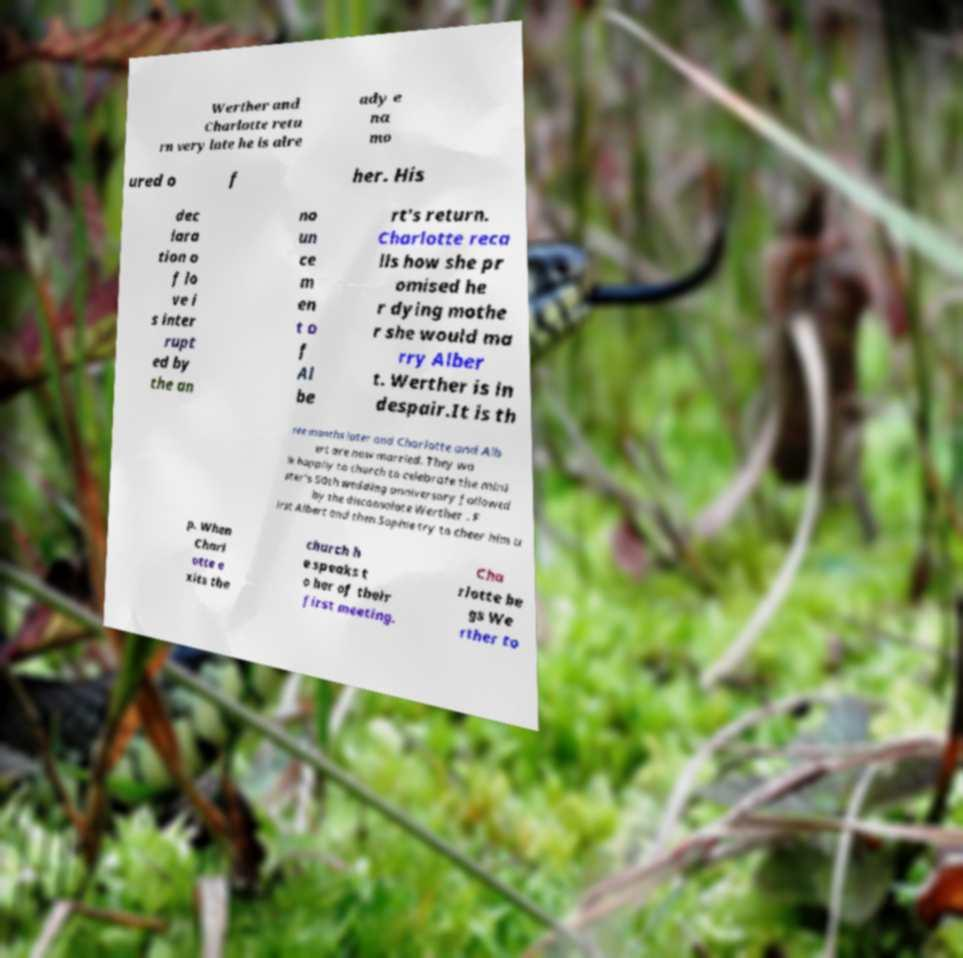For documentation purposes, I need the text within this image transcribed. Could you provide that? Werther and Charlotte retu rn very late he is alre ady e na mo ured o f her. His dec lara tion o f lo ve i s inter rupt ed by the an no un ce m en t o f Al be rt's return. Charlotte reca lls how she pr omised he r dying mothe r she would ma rry Alber t. Werther is in despair.It is th ree months later and Charlotte and Alb ert are now married. They wa lk happily to church to celebrate the mini ster's 50th wedding anniversary followed by the disconsolate Werther . F irst Albert and then Sophie try to cheer him u p. When Charl otte e xits the church h e speaks t o her of their first meeting. Cha rlotte be gs We rther to 